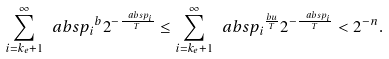<formula> <loc_0><loc_0><loc_500><loc_500>\sum _ { i = k _ { e } + 1 } ^ { \infty } \ a b s { p _ { i } } ^ { b } 2 ^ { - \frac { \ a b s { p _ { i } } } { T } } \leq \sum _ { i = k _ { e } + 1 } ^ { \infty } \ a b s { p _ { i } } ^ { \frac { b u } { T } } 2 ^ { - \frac { \ a b s { p _ { i } } } { T } } < 2 ^ { - n } .</formula> 